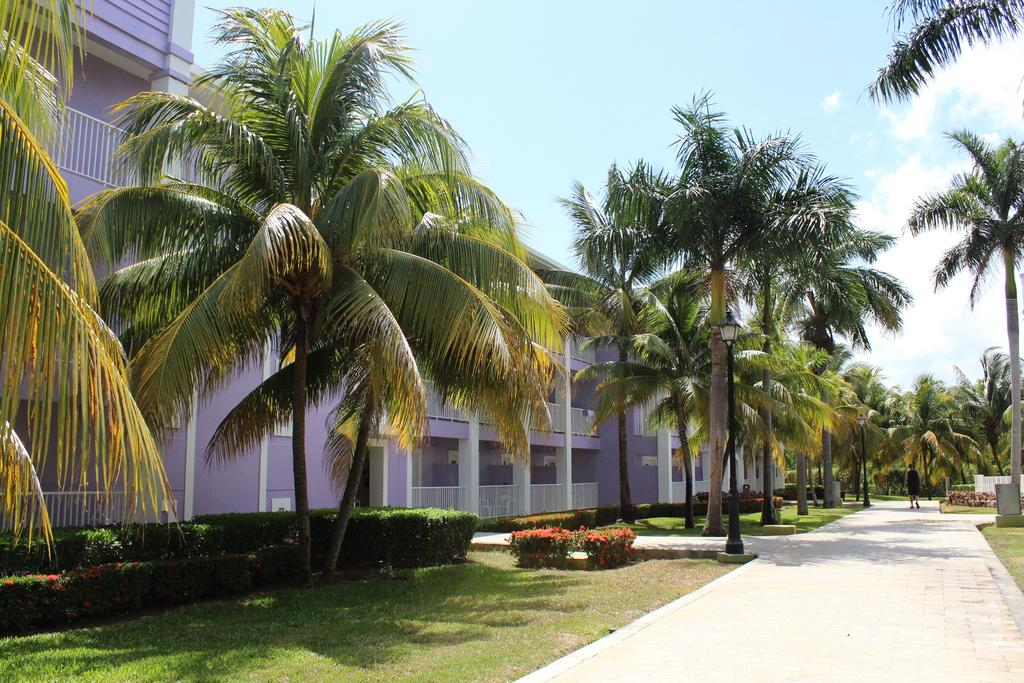What is the person in the image doing? The person in the image is walking on the road. What type of vegetation can be seen in the image? Grass, shrubs, and trees are visible in the image. What structures are present in the image? Light poles and a building are present in the image. What is visible in the background of the image? The sky, clouds, and a building are visible in the background of the image. What type of watch is the person wearing in the image? There is no watch visible on the person in the image. What payment method is being used for the person's walk in the image? There is no payment method mentioned or implied in the image; the person is simply walking on the road. 